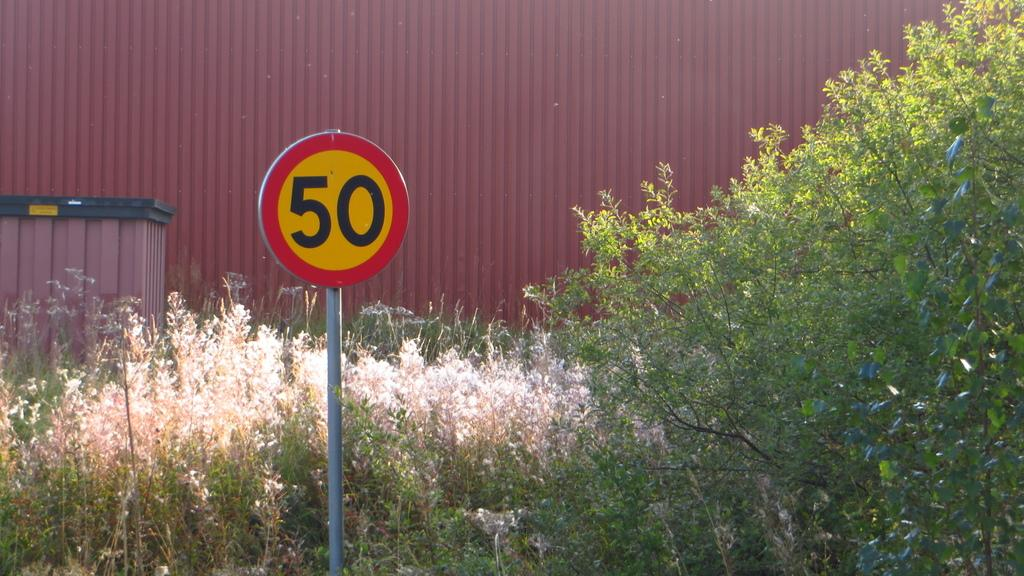Provide a one-sentence caption for the provided image. A yellow street sign labeled "50" stands in front of some weeds and a warehouse. 